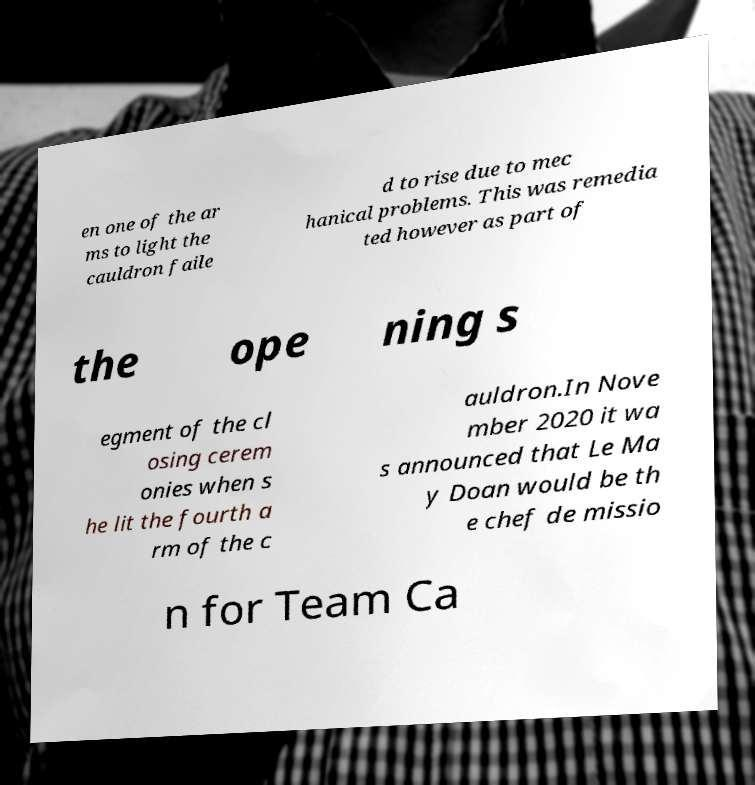For documentation purposes, I need the text within this image transcribed. Could you provide that? en one of the ar ms to light the cauldron faile d to rise due to mec hanical problems. This was remedia ted however as part of the ope ning s egment of the cl osing cerem onies when s he lit the fourth a rm of the c auldron.In Nove mber 2020 it wa s announced that Le Ma y Doan would be th e chef de missio n for Team Ca 